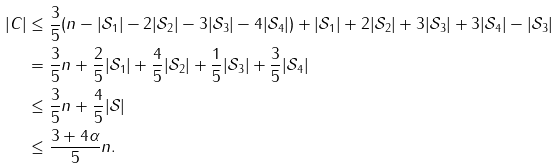<formula> <loc_0><loc_0><loc_500><loc_500>| C | & \leq \frac { 3 } { 5 } ( n - | \mathcal { S } _ { 1 } | - 2 | \mathcal { S } _ { 2 } | - 3 | \mathcal { S } _ { 3 } | - 4 | \mathcal { S } _ { 4 } | ) + | \mathcal { S } _ { 1 } | + 2 | \mathcal { S } _ { 2 } | + 3 | \mathcal { S } _ { 3 } | + 3 | \mathcal { S } _ { 4 } | - | \mathcal { S } _ { 3 } | \\ & = \frac { 3 } { 5 } n + \frac { 2 } { 5 } | \mathcal { S } _ { 1 } | + \frac { 4 } { 5 } | \mathcal { S } _ { 2 } | + \frac { 1 } { 5 } | \mathcal { S } _ { 3 } | + \frac { 3 } { 5 } | \mathcal { S } _ { 4 } | \\ & \leq \frac { 3 } { 5 } n + \frac { 4 } { 5 } | \mathcal { S } | \\ & \leq \frac { 3 + 4 \alpha } { 5 } n .</formula> 